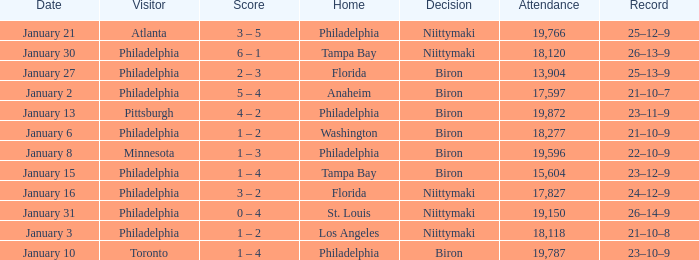What is the decision of the game on January 13? Biron. 